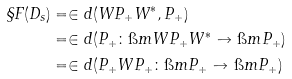<formula> <loc_0><loc_0><loc_500><loc_500>\S F ( D _ { s } ) & = \in d ( W P _ { + } W ^ { * } , P _ { + } ) \\ & = \in d ( P _ { + } \colon \i m W P _ { + } W ^ { * } \to \i m P _ { + } ) \\ & = \in d ( P _ { + } W P _ { + } \colon \i m P _ { + } \to \i m P _ { + } )</formula> 